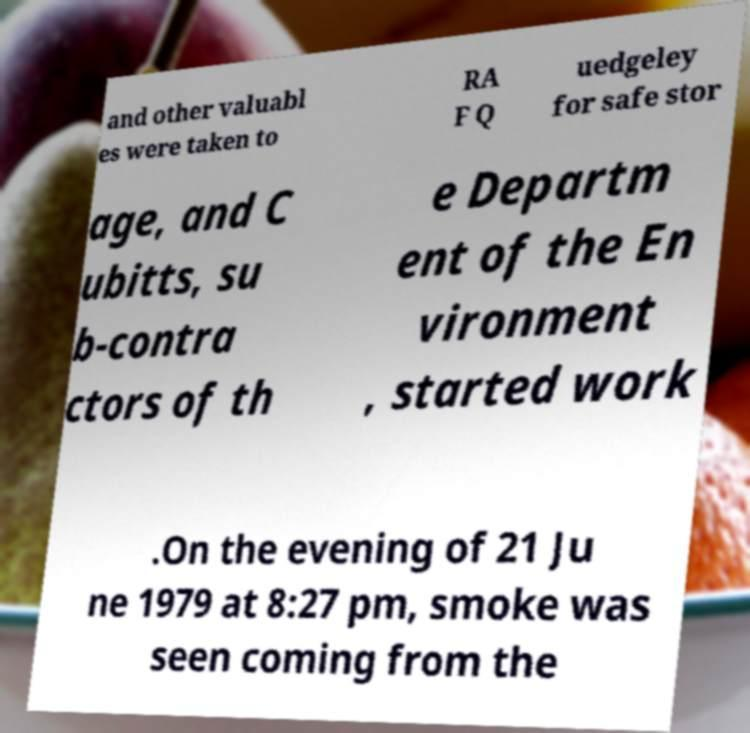Please read and relay the text visible in this image. What does it say? and other valuabl es were taken to RA F Q uedgeley for safe stor age, and C ubitts, su b-contra ctors of th e Departm ent of the En vironment , started work .On the evening of 21 Ju ne 1979 at 8:27 pm, smoke was seen coming from the 